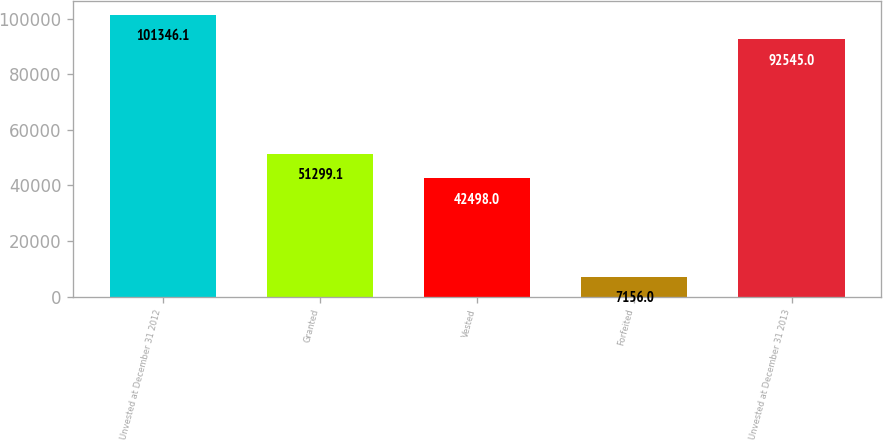Convert chart to OTSL. <chart><loc_0><loc_0><loc_500><loc_500><bar_chart><fcel>Unvested at December 31 2012<fcel>Granted<fcel>Vested<fcel>Forfeited<fcel>Unvested at December 31 2013<nl><fcel>101346<fcel>51299.1<fcel>42498<fcel>7156<fcel>92545<nl></chart> 